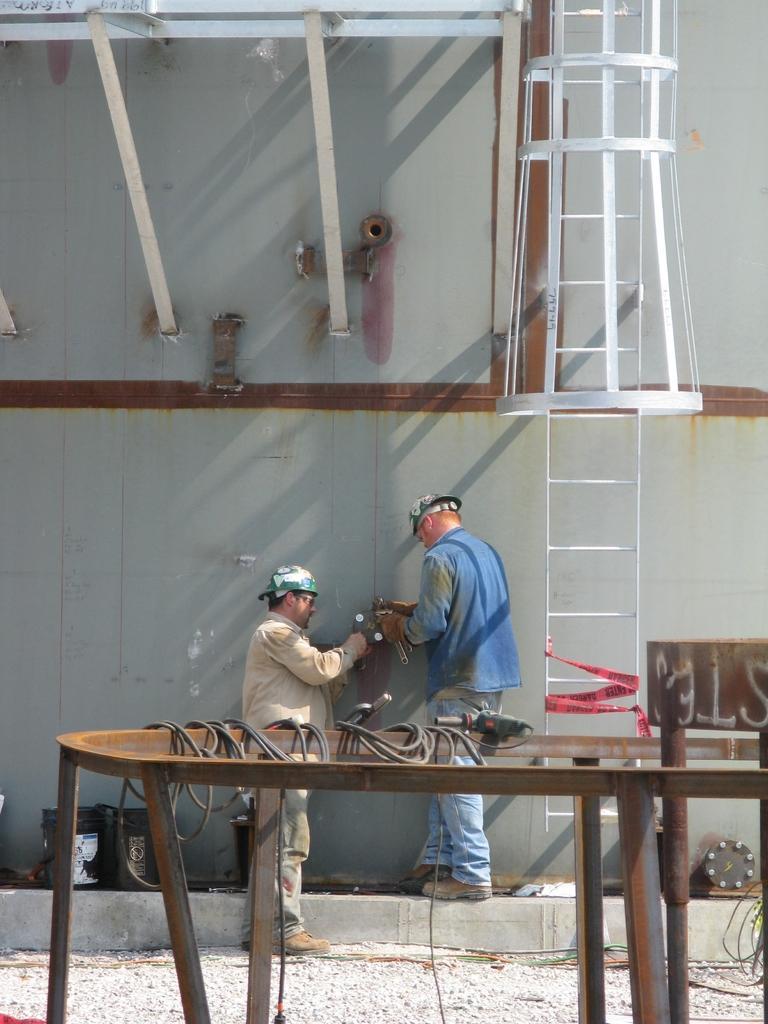Could you give a brief overview of what you see in this image? in this image i can see two persons standing. at the right side there is a ladder. 